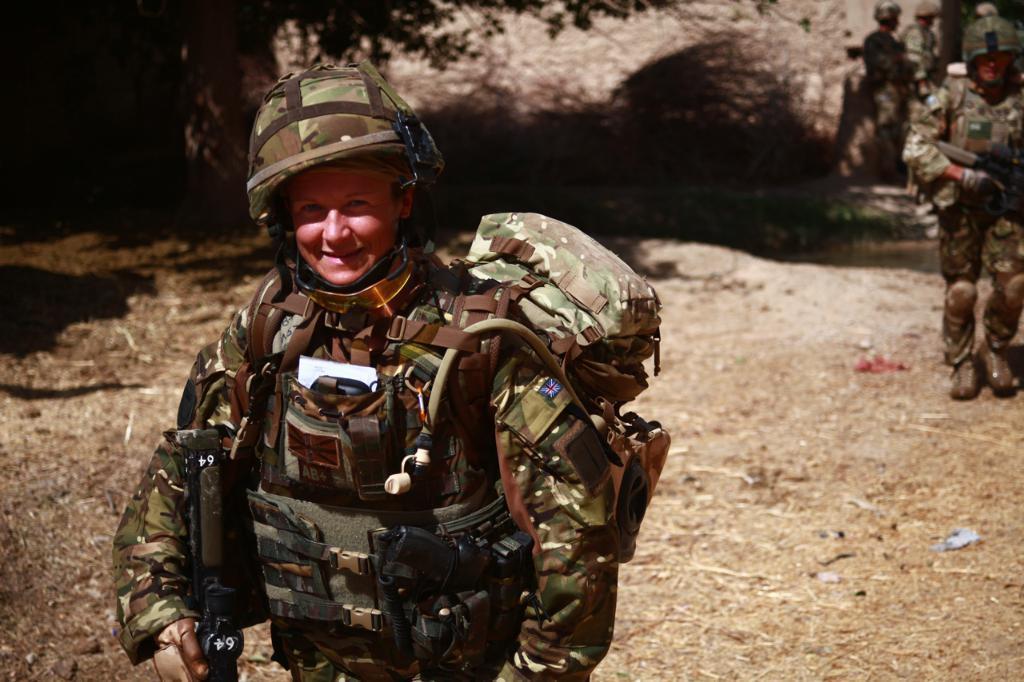Can you describe this image briefly? In this image there is a person standing on the ground. The person is smiling. The person is holding a rifle in the hand. To the right there are a few people standing on the ground. At the top there are leaves of a tree. 